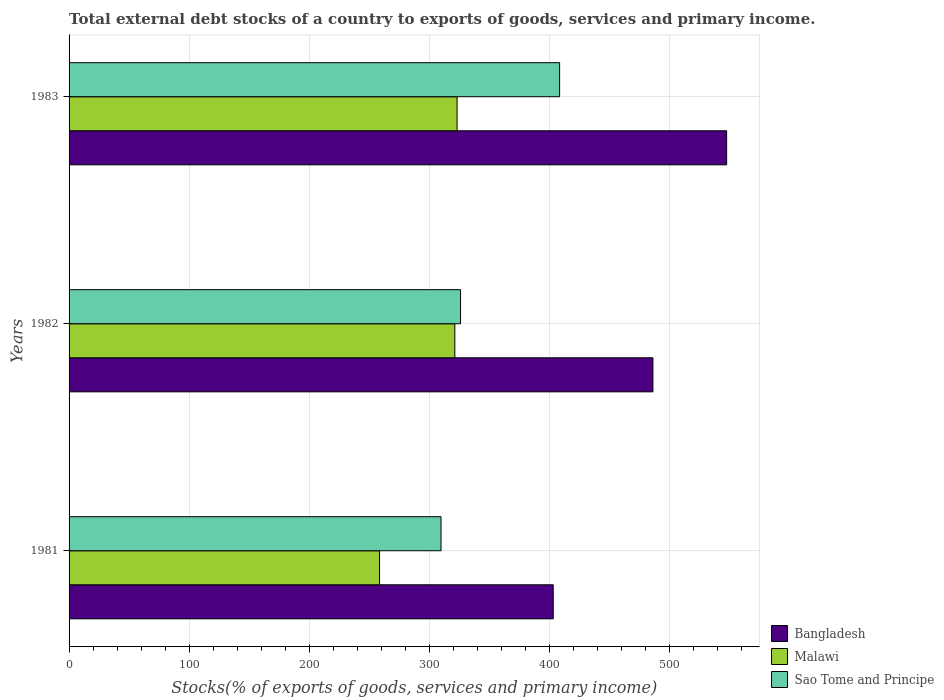How many groups of bars are there?
Provide a short and direct response. 3. How many bars are there on the 2nd tick from the top?
Provide a succinct answer. 3. What is the label of the 2nd group of bars from the top?
Offer a very short reply. 1982. In how many cases, is the number of bars for a given year not equal to the number of legend labels?
Offer a very short reply. 0. What is the total debt stocks in Bangladesh in 1982?
Provide a short and direct response. 486.47. Across all years, what is the maximum total debt stocks in Malawi?
Give a very brief answer. 323.29. Across all years, what is the minimum total debt stocks in Malawi?
Give a very brief answer. 258.72. In which year was the total debt stocks in Bangladesh maximum?
Your answer should be compact. 1983. What is the total total debt stocks in Malawi in the graph?
Your answer should be compact. 903.42. What is the difference between the total debt stocks in Malawi in 1981 and that in 1982?
Offer a very short reply. -62.7. What is the difference between the total debt stocks in Bangladesh in 1983 and the total debt stocks in Malawi in 1982?
Provide a short and direct response. 226.48. What is the average total debt stocks in Bangladesh per year?
Offer a very short reply. 479.26. In the year 1983, what is the difference between the total debt stocks in Sao Tome and Principe and total debt stocks in Malawi?
Offer a very short reply. 85.44. What is the ratio of the total debt stocks in Bangladesh in 1982 to that in 1983?
Offer a very short reply. 0.89. Is the total debt stocks in Sao Tome and Principe in 1981 less than that in 1982?
Your response must be concise. Yes. What is the difference between the highest and the second highest total debt stocks in Bangladesh?
Keep it short and to the point. 61.43. What is the difference between the highest and the lowest total debt stocks in Malawi?
Your response must be concise. 64.57. What does the 2nd bar from the top in 1983 represents?
Keep it short and to the point. Malawi. What does the 2nd bar from the bottom in 1983 represents?
Ensure brevity in your answer.  Malawi. Are all the bars in the graph horizontal?
Ensure brevity in your answer.  Yes. Does the graph contain grids?
Your answer should be very brief. Yes. Where does the legend appear in the graph?
Your answer should be compact. Bottom right. How many legend labels are there?
Provide a succinct answer. 3. What is the title of the graph?
Your answer should be very brief. Total external debt stocks of a country to exports of goods, services and primary income. What is the label or title of the X-axis?
Your answer should be compact. Stocks(% of exports of goods, services and primary income). What is the Stocks(% of exports of goods, services and primary income) of Bangladesh in 1981?
Provide a short and direct response. 403.41. What is the Stocks(% of exports of goods, services and primary income) in Malawi in 1981?
Offer a very short reply. 258.72. What is the Stocks(% of exports of goods, services and primary income) in Sao Tome and Principe in 1981?
Ensure brevity in your answer.  309.91. What is the Stocks(% of exports of goods, services and primary income) of Bangladesh in 1982?
Your response must be concise. 486.47. What is the Stocks(% of exports of goods, services and primary income) in Malawi in 1982?
Your response must be concise. 321.42. What is the Stocks(% of exports of goods, services and primary income) of Sao Tome and Principe in 1982?
Make the answer very short. 326.16. What is the Stocks(% of exports of goods, services and primary income) in Bangladesh in 1983?
Ensure brevity in your answer.  547.9. What is the Stocks(% of exports of goods, services and primary income) of Malawi in 1983?
Provide a succinct answer. 323.29. What is the Stocks(% of exports of goods, services and primary income) of Sao Tome and Principe in 1983?
Provide a succinct answer. 408.73. Across all years, what is the maximum Stocks(% of exports of goods, services and primary income) of Bangladesh?
Keep it short and to the point. 547.9. Across all years, what is the maximum Stocks(% of exports of goods, services and primary income) of Malawi?
Keep it short and to the point. 323.29. Across all years, what is the maximum Stocks(% of exports of goods, services and primary income) in Sao Tome and Principe?
Your answer should be compact. 408.73. Across all years, what is the minimum Stocks(% of exports of goods, services and primary income) in Bangladesh?
Your answer should be compact. 403.41. Across all years, what is the minimum Stocks(% of exports of goods, services and primary income) of Malawi?
Your answer should be very brief. 258.72. Across all years, what is the minimum Stocks(% of exports of goods, services and primary income) in Sao Tome and Principe?
Your answer should be very brief. 309.91. What is the total Stocks(% of exports of goods, services and primary income) of Bangladesh in the graph?
Offer a very short reply. 1437.78. What is the total Stocks(% of exports of goods, services and primary income) in Malawi in the graph?
Provide a short and direct response. 903.42. What is the total Stocks(% of exports of goods, services and primary income) of Sao Tome and Principe in the graph?
Provide a succinct answer. 1044.79. What is the difference between the Stocks(% of exports of goods, services and primary income) in Bangladesh in 1981 and that in 1982?
Provide a short and direct response. -83.06. What is the difference between the Stocks(% of exports of goods, services and primary income) of Malawi in 1981 and that in 1982?
Provide a short and direct response. -62.7. What is the difference between the Stocks(% of exports of goods, services and primary income) of Sao Tome and Principe in 1981 and that in 1982?
Keep it short and to the point. -16.26. What is the difference between the Stocks(% of exports of goods, services and primary income) in Bangladesh in 1981 and that in 1983?
Give a very brief answer. -144.48. What is the difference between the Stocks(% of exports of goods, services and primary income) of Malawi in 1981 and that in 1983?
Your response must be concise. -64.57. What is the difference between the Stocks(% of exports of goods, services and primary income) in Sao Tome and Principe in 1981 and that in 1983?
Keep it short and to the point. -98.82. What is the difference between the Stocks(% of exports of goods, services and primary income) of Bangladesh in 1982 and that in 1983?
Give a very brief answer. -61.43. What is the difference between the Stocks(% of exports of goods, services and primary income) of Malawi in 1982 and that in 1983?
Provide a succinct answer. -1.87. What is the difference between the Stocks(% of exports of goods, services and primary income) of Sao Tome and Principe in 1982 and that in 1983?
Provide a short and direct response. -82.57. What is the difference between the Stocks(% of exports of goods, services and primary income) in Bangladesh in 1981 and the Stocks(% of exports of goods, services and primary income) in Malawi in 1982?
Offer a very short reply. 82. What is the difference between the Stocks(% of exports of goods, services and primary income) of Bangladesh in 1981 and the Stocks(% of exports of goods, services and primary income) of Sao Tome and Principe in 1982?
Your answer should be compact. 77.25. What is the difference between the Stocks(% of exports of goods, services and primary income) of Malawi in 1981 and the Stocks(% of exports of goods, services and primary income) of Sao Tome and Principe in 1982?
Your answer should be very brief. -67.44. What is the difference between the Stocks(% of exports of goods, services and primary income) in Bangladesh in 1981 and the Stocks(% of exports of goods, services and primary income) in Malawi in 1983?
Provide a succinct answer. 80.13. What is the difference between the Stocks(% of exports of goods, services and primary income) in Bangladesh in 1981 and the Stocks(% of exports of goods, services and primary income) in Sao Tome and Principe in 1983?
Your answer should be compact. -5.31. What is the difference between the Stocks(% of exports of goods, services and primary income) in Malawi in 1981 and the Stocks(% of exports of goods, services and primary income) in Sao Tome and Principe in 1983?
Offer a very short reply. -150.01. What is the difference between the Stocks(% of exports of goods, services and primary income) in Bangladesh in 1982 and the Stocks(% of exports of goods, services and primary income) in Malawi in 1983?
Ensure brevity in your answer.  163.19. What is the difference between the Stocks(% of exports of goods, services and primary income) of Bangladesh in 1982 and the Stocks(% of exports of goods, services and primary income) of Sao Tome and Principe in 1983?
Your answer should be compact. 77.75. What is the difference between the Stocks(% of exports of goods, services and primary income) in Malawi in 1982 and the Stocks(% of exports of goods, services and primary income) in Sao Tome and Principe in 1983?
Your answer should be compact. -87.31. What is the average Stocks(% of exports of goods, services and primary income) in Bangladesh per year?
Keep it short and to the point. 479.26. What is the average Stocks(% of exports of goods, services and primary income) in Malawi per year?
Provide a succinct answer. 301.14. What is the average Stocks(% of exports of goods, services and primary income) in Sao Tome and Principe per year?
Your answer should be very brief. 348.26. In the year 1981, what is the difference between the Stocks(% of exports of goods, services and primary income) of Bangladesh and Stocks(% of exports of goods, services and primary income) of Malawi?
Your answer should be compact. 144.7. In the year 1981, what is the difference between the Stocks(% of exports of goods, services and primary income) of Bangladesh and Stocks(% of exports of goods, services and primary income) of Sao Tome and Principe?
Your answer should be very brief. 93.51. In the year 1981, what is the difference between the Stocks(% of exports of goods, services and primary income) of Malawi and Stocks(% of exports of goods, services and primary income) of Sao Tome and Principe?
Give a very brief answer. -51.19. In the year 1982, what is the difference between the Stocks(% of exports of goods, services and primary income) in Bangladesh and Stocks(% of exports of goods, services and primary income) in Malawi?
Your response must be concise. 165.05. In the year 1982, what is the difference between the Stocks(% of exports of goods, services and primary income) of Bangladesh and Stocks(% of exports of goods, services and primary income) of Sao Tome and Principe?
Give a very brief answer. 160.31. In the year 1982, what is the difference between the Stocks(% of exports of goods, services and primary income) of Malawi and Stocks(% of exports of goods, services and primary income) of Sao Tome and Principe?
Offer a terse response. -4.74. In the year 1983, what is the difference between the Stocks(% of exports of goods, services and primary income) of Bangladesh and Stocks(% of exports of goods, services and primary income) of Malawi?
Keep it short and to the point. 224.61. In the year 1983, what is the difference between the Stocks(% of exports of goods, services and primary income) of Bangladesh and Stocks(% of exports of goods, services and primary income) of Sao Tome and Principe?
Your response must be concise. 139.17. In the year 1983, what is the difference between the Stocks(% of exports of goods, services and primary income) of Malawi and Stocks(% of exports of goods, services and primary income) of Sao Tome and Principe?
Your response must be concise. -85.44. What is the ratio of the Stocks(% of exports of goods, services and primary income) of Bangladesh in 1981 to that in 1982?
Offer a terse response. 0.83. What is the ratio of the Stocks(% of exports of goods, services and primary income) in Malawi in 1981 to that in 1982?
Ensure brevity in your answer.  0.8. What is the ratio of the Stocks(% of exports of goods, services and primary income) in Sao Tome and Principe in 1981 to that in 1982?
Give a very brief answer. 0.95. What is the ratio of the Stocks(% of exports of goods, services and primary income) in Bangladesh in 1981 to that in 1983?
Keep it short and to the point. 0.74. What is the ratio of the Stocks(% of exports of goods, services and primary income) in Malawi in 1981 to that in 1983?
Give a very brief answer. 0.8. What is the ratio of the Stocks(% of exports of goods, services and primary income) in Sao Tome and Principe in 1981 to that in 1983?
Give a very brief answer. 0.76. What is the ratio of the Stocks(% of exports of goods, services and primary income) in Bangladesh in 1982 to that in 1983?
Ensure brevity in your answer.  0.89. What is the ratio of the Stocks(% of exports of goods, services and primary income) in Malawi in 1982 to that in 1983?
Provide a short and direct response. 0.99. What is the ratio of the Stocks(% of exports of goods, services and primary income) of Sao Tome and Principe in 1982 to that in 1983?
Your response must be concise. 0.8. What is the difference between the highest and the second highest Stocks(% of exports of goods, services and primary income) of Bangladesh?
Offer a very short reply. 61.43. What is the difference between the highest and the second highest Stocks(% of exports of goods, services and primary income) in Malawi?
Provide a short and direct response. 1.87. What is the difference between the highest and the second highest Stocks(% of exports of goods, services and primary income) of Sao Tome and Principe?
Ensure brevity in your answer.  82.57. What is the difference between the highest and the lowest Stocks(% of exports of goods, services and primary income) in Bangladesh?
Keep it short and to the point. 144.48. What is the difference between the highest and the lowest Stocks(% of exports of goods, services and primary income) in Malawi?
Ensure brevity in your answer.  64.57. What is the difference between the highest and the lowest Stocks(% of exports of goods, services and primary income) in Sao Tome and Principe?
Your answer should be compact. 98.82. 